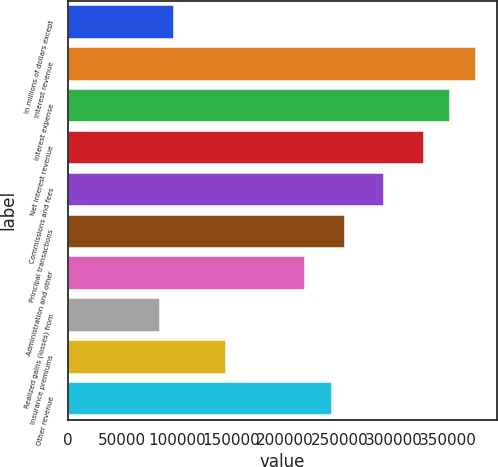Convert chart to OTSL. <chart><loc_0><loc_0><loc_500><loc_500><bar_chart><fcel>In millions of dollars except<fcel>Interest revenue<fcel>Interest expense<fcel>Net interest revenue<fcel>Commissions and fees<fcel>Principal transactions<fcel>Administration and other<fcel>Realized gains (losses) from<fcel>Insurance premiums<fcel>Other revenue<nl><fcel>97173.2<fcel>376115<fcel>351859<fcel>327603<fcel>291220<fcel>254836<fcel>218452<fcel>85045.3<fcel>145685<fcel>242708<nl></chart> 